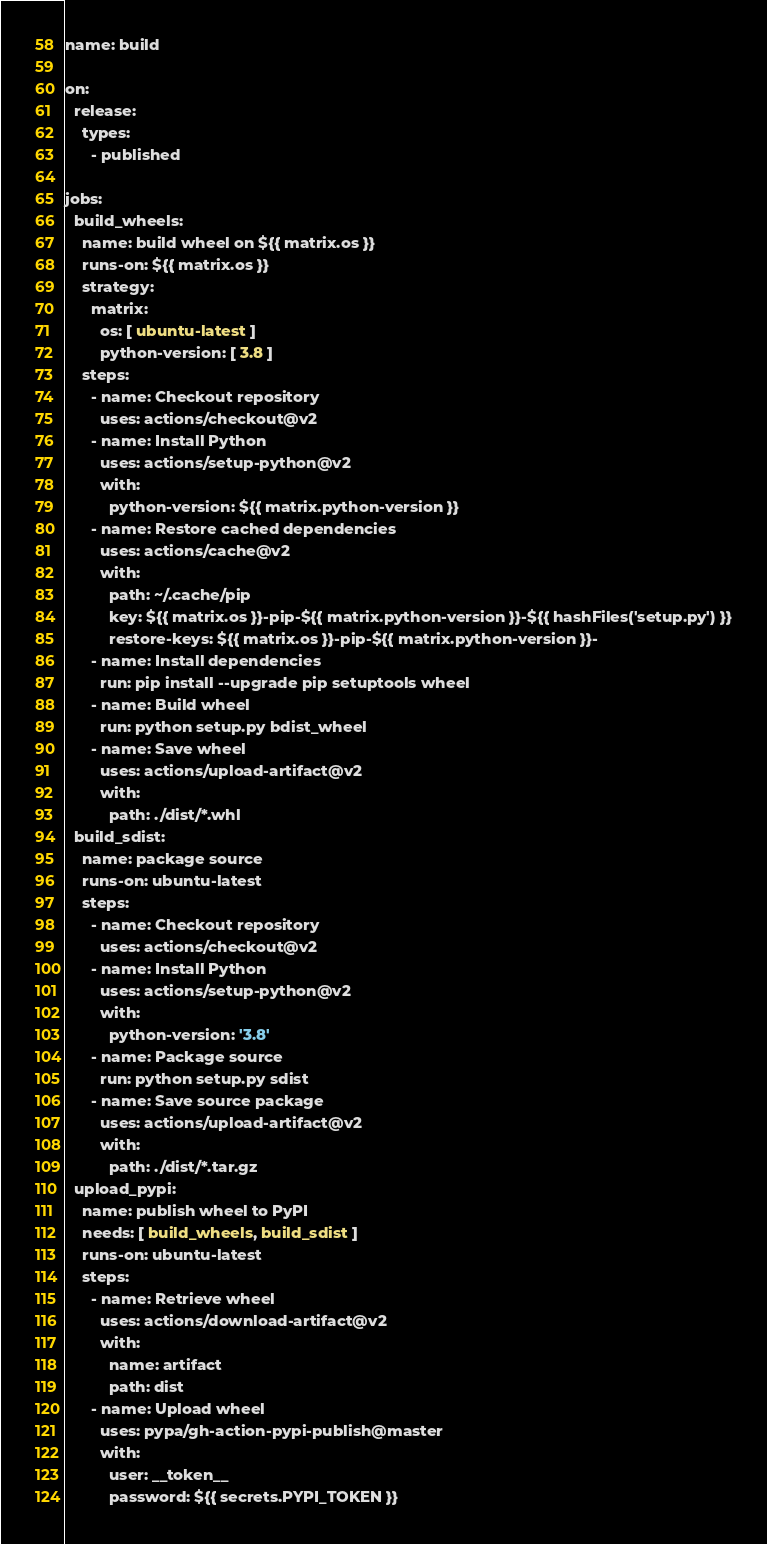Convert code to text. <code><loc_0><loc_0><loc_500><loc_500><_YAML_>name: build

on:
  release:
    types:
      - published

jobs:
  build_wheels:
    name: build wheel on ${{ matrix.os }}
    runs-on: ${{ matrix.os }}
    strategy:
      matrix:
        os: [ ubuntu-latest ]
        python-version: [ 3.8 ]
    steps:
      - name: Checkout repository
        uses: actions/checkout@v2
      - name: Install Python
        uses: actions/setup-python@v2
        with:
          python-version: ${{ matrix.python-version }}
      - name: Restore cached dependencies
        uses: actions/cache@v2
        with:
          path: ~/.cache/pip
          key: ${{ matrix.os }}-pip-${{ matrix.python-version }}-${{ hashFiles('setup.py') }}
          restore-keys: ${{ matrix.os }}-pip-${{ matrix.python-version }}-
      - name: Install dependencies
        run: pip install --upgrade pip setuptools wheel
      - name: Build wheel
        run: python setup.py bdist_wheel
      - name: Save wheel
        uses: actions/upload-artifact@v2
        with:
          path: ./dist/*.whl
  build_sdist:
    name: package source
    runs-on: ubuntu-latest
    steps:
      - name: Checkout repository
        uses: actions/checkout@v2
      - name: Install Python
        uses: actions/setup-python@v2
        with:
          python-version: '3.8'
      - name: Package source
        run: python setup.py sdist
      - name: Save source package
        uses: actions/upload-artifact@v2
        with:
          path: ./dist/*.tar.gz
  upload_pypi:
    name: publish wheel to PyPI
    needs: [ build_wheels, build_sdist ]
    runs-on: ubuntu-latest
    steps:
      - name: Retrieve wheel
        uses: actions/download-artifact@v2
        with:
          name: artifact
          path: dist
      - name: Upload wheel
        uses: pypa/gh-action-pypi-publish@master
        with:
          user: __token__
          password: ${{ secrets.PYPI_TOKEN }}</code> 